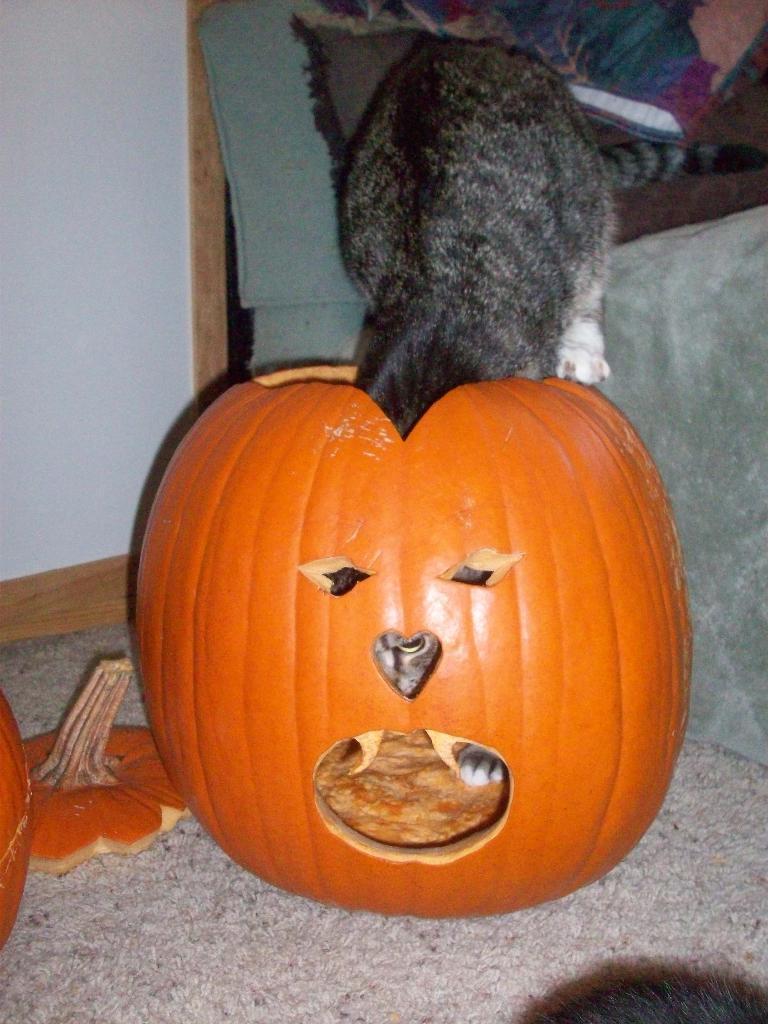Please provide a concise description of this image. This picture contains carved pumpkin. The cat in black color is entering into the carved pumpkin. Behind that, we see a sofa in grey color. On the left side, we see a wall in white color. 